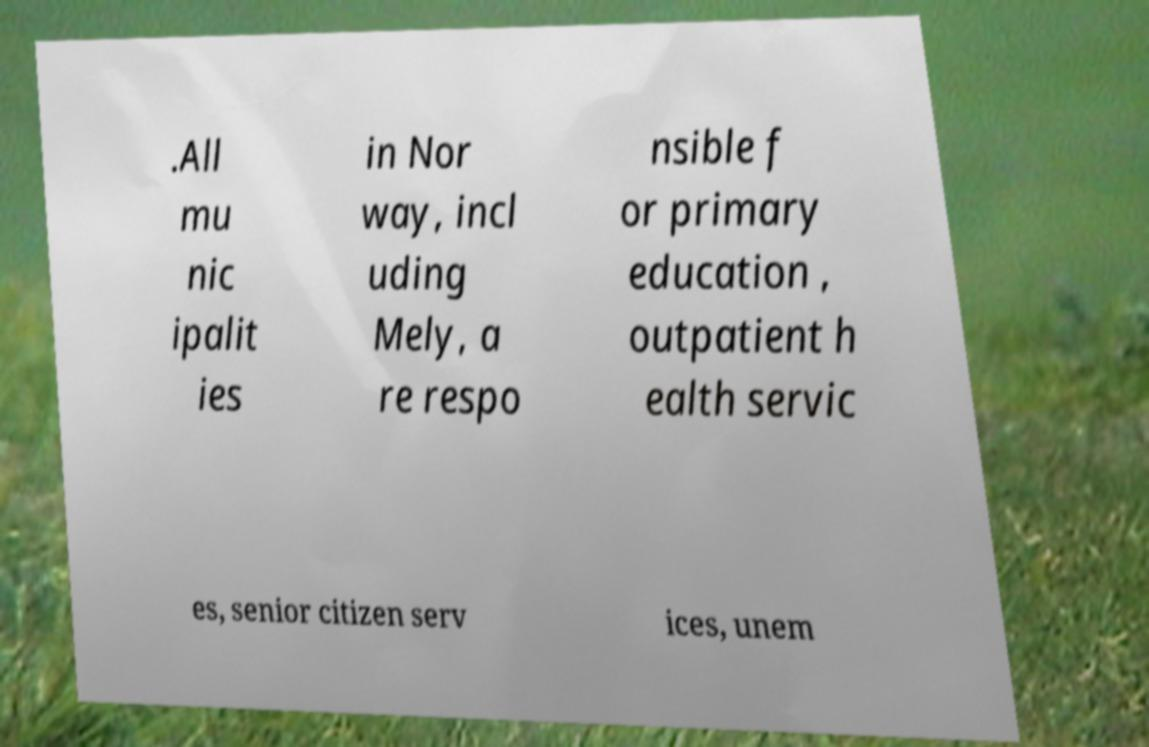Please identify and transcribe the text found in this image. .All mu nic ipalit ies in Nor way, incl uding Mely, a re respo nsible f or primary education , outpatient h ealth servic es, senior citizen serv ices, unem 